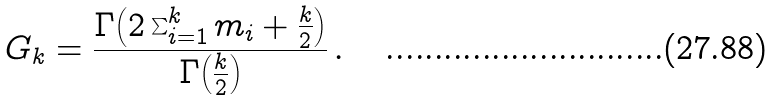<formula> <loc_0><loc_0><loc_500><loc_500>G _ { k } = \frac { \Gamma { \left ( 2 \sum _ { i = 1 } ^ { k } { m _ { i } } + \frac { k } { 2 } \right ) } } { \Gamma { \left ( \frac { k } { 2 } \right ) } } \, .</formula> 